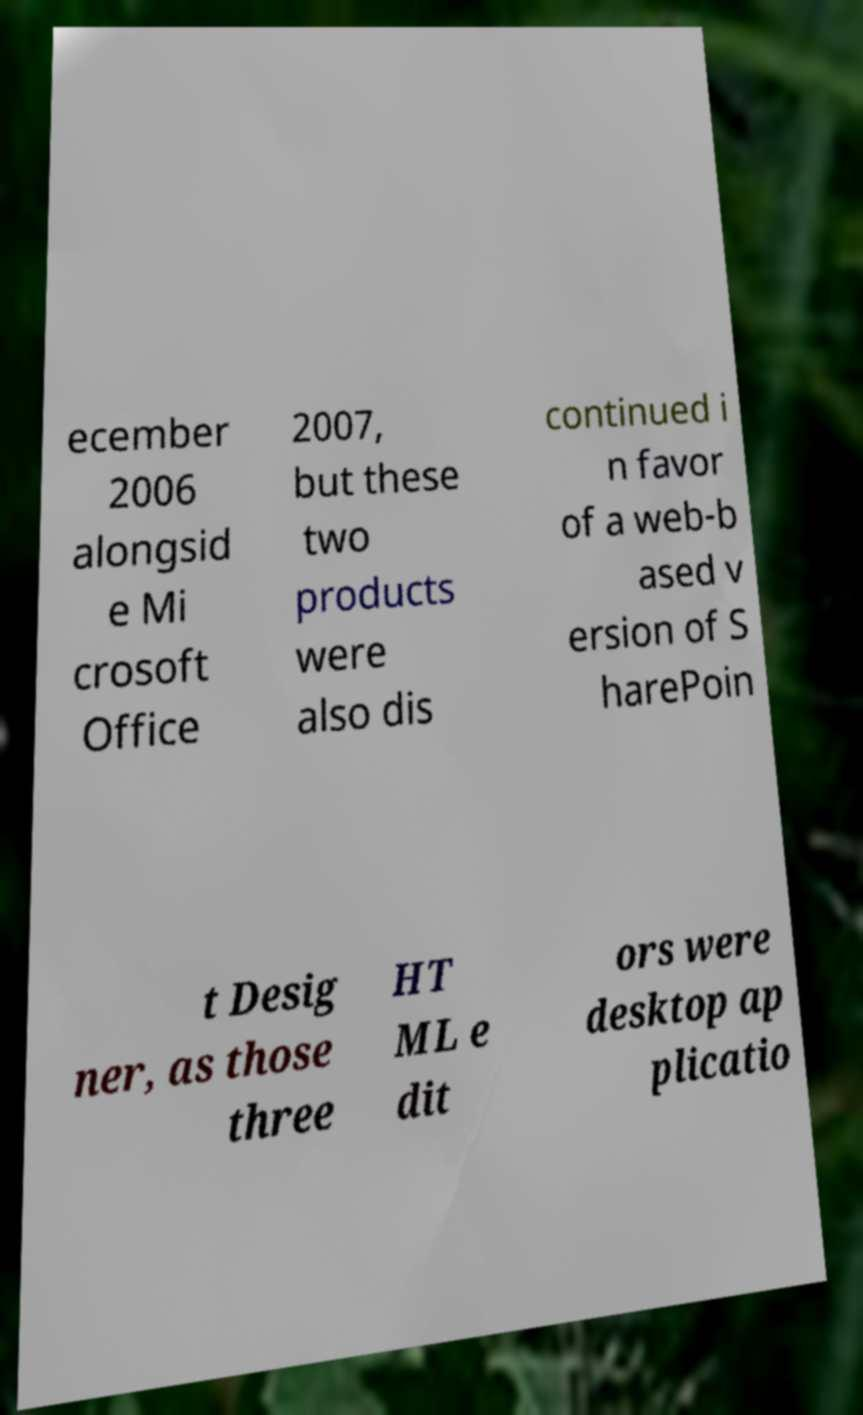Can you accurately transcribe the text from the provided image for me? ecember 2006 alongsid e Mi crosoft Office 2007, but these two products were also dis continued i n favor of a web-b ased v ersion of S harePoin t Desig ner, as those three HT ML e dit ors were desktop ap plicatio 